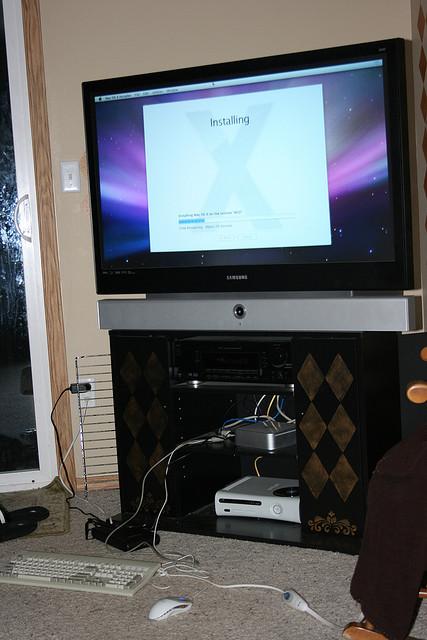What electronics are under the TV?
Short answer required. Wii. Is the television turned on?
Be succinct. Yes. Is this a large screen television?
Quick response, please. Yes. What scene is on TV?
Give a very brief answer. Installing software. 